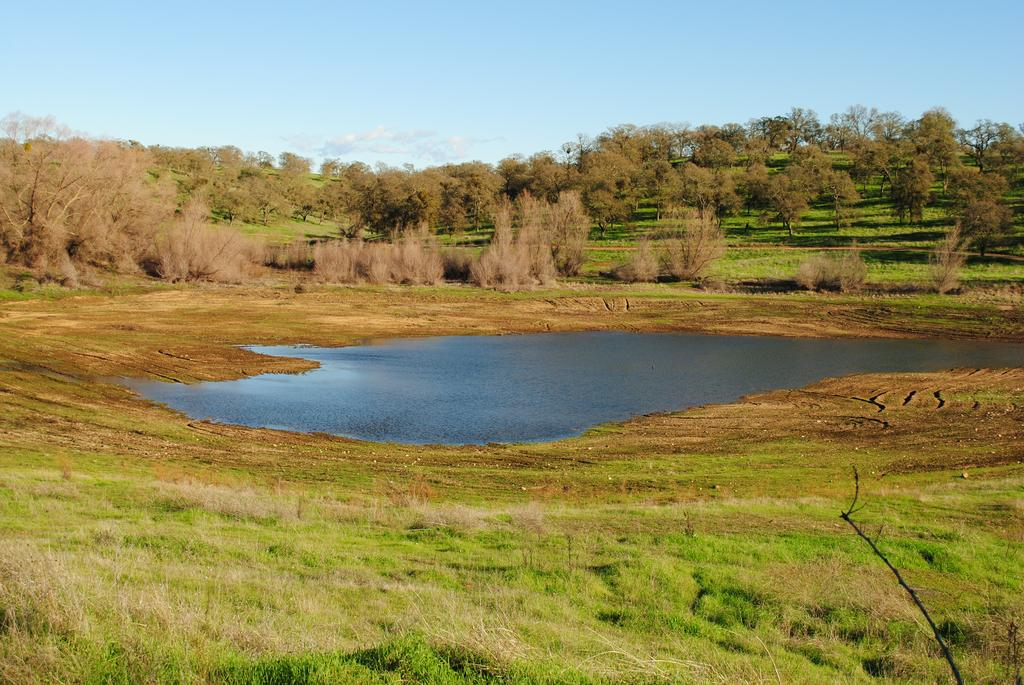What can be seen in the sky in the image? The sky with clouds is visible in the image. What type of vegetation is present in the image? There are trees, shrubs, and bushes in the image. What is visible on the ground in the image? The ground, grass, and a pond are visible in the image. How many toy trucks are present in the image? There are no toy trucks present in the image. What type of detail can be seen on the pond in the image? The image does not provide enough detail to determine any specific features of the pond. 